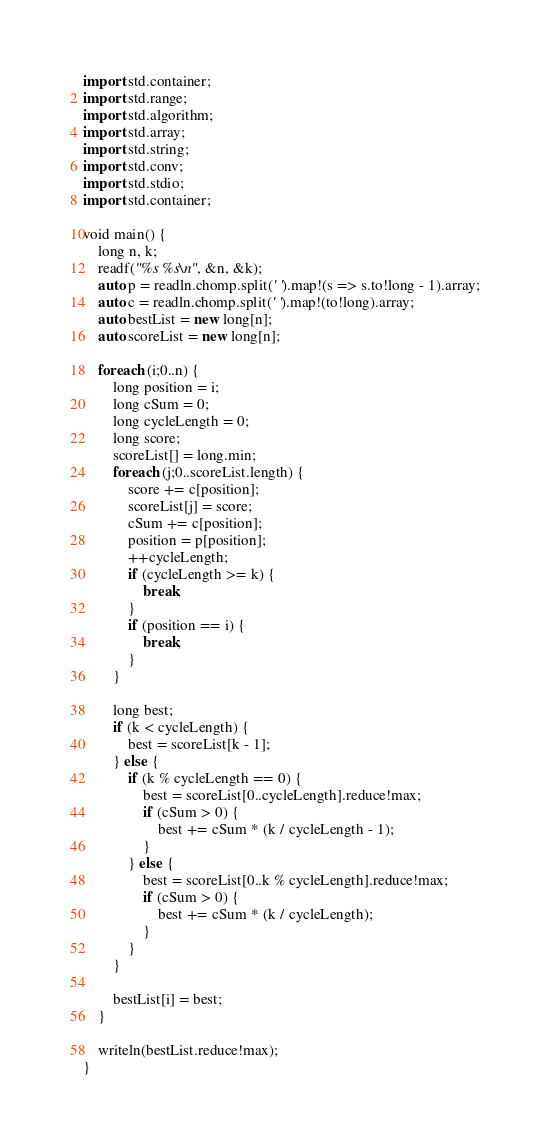Convert code to text. <code><loc_0><loc_0><loc_500><loc_500><_D_>import std.container;
import std.range;
import std.algorithm;
import std.array;
import std.string;
import std.conv;
import std.stdio;
import std.container;

void main() {
	long n, k;
	readf("%s %s\n", &n, &k);
	auto p = readln.chomp.split(' ').map!(s => s.to!long - 1).array;
	auto c = readln.chomp.split(' ').map!(to!long).array;
	auto bestList = new long[n];
	auto scoreList = new long[n];

	foreach (i;0..n) {
		long position = i;
		long cSum = 0;
		long cycleLength = 0;
		long score;
		scoreList[] = long.min;
		foreach (j;0..scoreList.length) {
			score += c[position];
			scoreList[j] = score;
			cSum += c[position];
			position = p[position];
			++cycleLength;
			if (cycleLength >= k) {
				break;
			}
			if (position == i) {
				break;
			}
		}

		long best;
		if (k < cycleLength) {
			best = scoreList[k - 1];
		} else {
			if (k % cycleLength == 0) {
				best = scoreList[0..cycleLength].reduce!max;
				if (cSum > 0) {
					best += cSum * (k / cycleLength - 1);
				}
			} else {
				best = scoreList[0..k % cycleLength].reduce!max;
				if (cSum > 0) {
					best += cSum * (k / cycleLength);
				}
			}
		}

		bestList[i] = best;
	}

	writeln(bestList.reduce!max);
}
</code> 